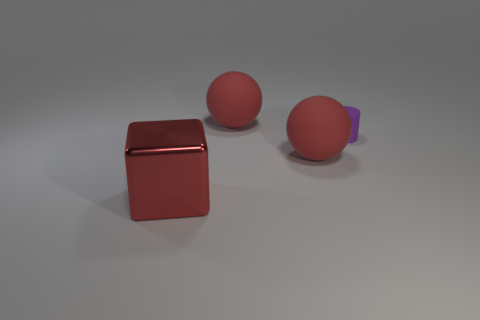Are there any other things that have the same size as the purple matte cylinder?
Your answer should be very brief. No. What number of balls are the same material as the block?
Give a very brief answer. 0. The metal object has what color?
Offer a very short reply. Red. Is the shape of the red matte object that is in front of the purple thing the same as the large matte thing that is behind the tiny purple thing?
Your response must be concise. Yes. There is a matte sphere behind the tiny purple cylinder; what is its color?
Your answer should be very brief. Red. Are there fewer red matte objects right of the small thing than matte balls that are behind the big red metallic block?
Ensure brevity in your answer.  Yes. What number of other things are there of the same material as the small thing
Your answer should be very brief. 2. Do the big block and the tiny thing have the same material?
Your answer should be very brief. No. What number of other things are the same size as the purple matte thing?
Give a very brief answer. 0. What is the size of the matte ball that is in front of the big red thing behind the tiny matte object?
Your answer should be compact. Large. 